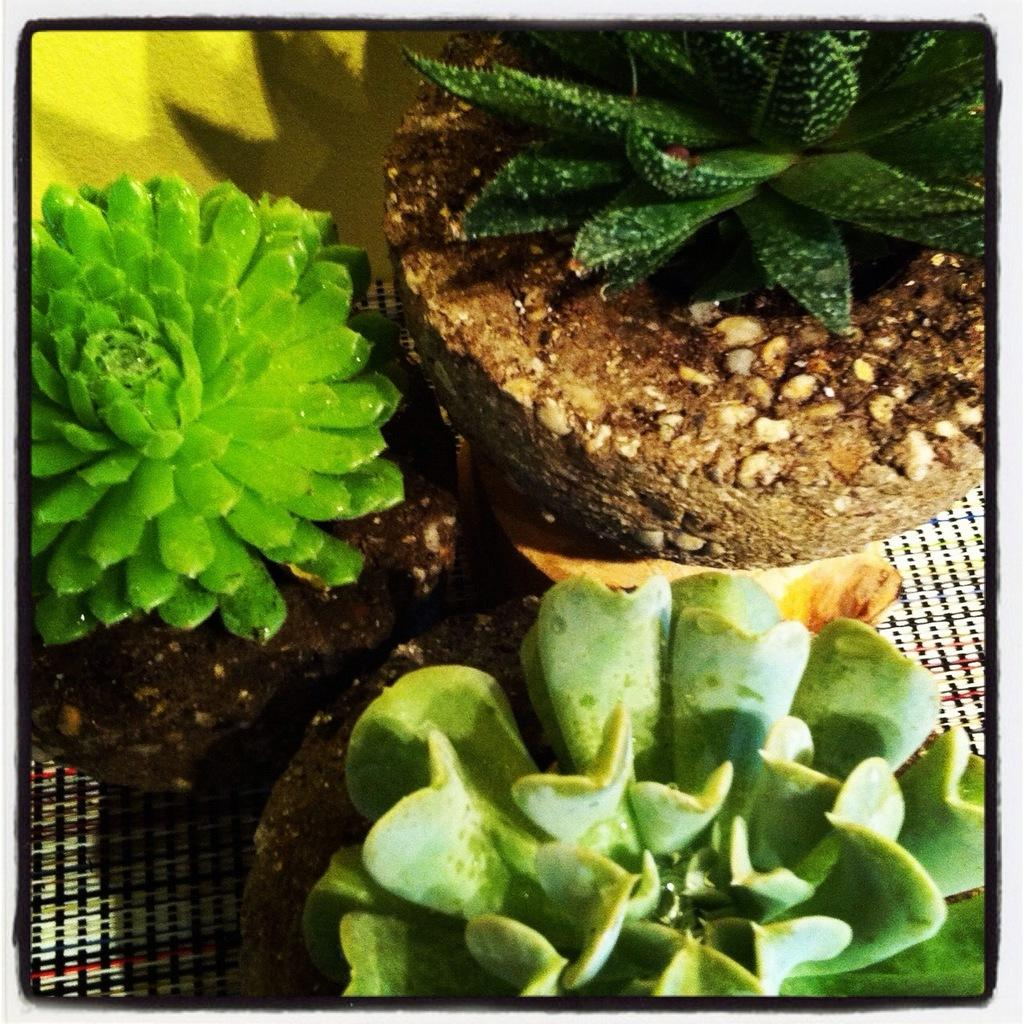What feature surrounds the main content of the image? The image has borders. What type of plants are depicted in the center of the image? The objects in the center of the image resemble succulent plants. What else can be seen in the image besides the succulent plants? There are other objects visible in the background of the image. What type of treatment is being administered to the fifth succulent plant in the image? There is no indication of any treatment being administered to any succulent plants in the image, and there is no mention of a fifth plant. 